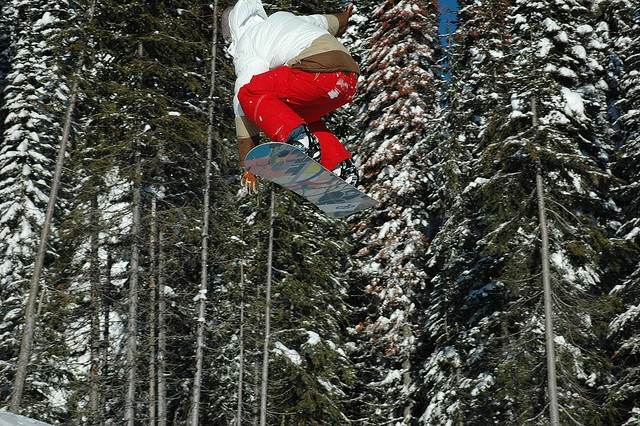Describe the objects in this image and their specific colors. I can see people in black, lightgray, brown, and maroon tones and snowboard in black, gray, and blue tones in this image. 